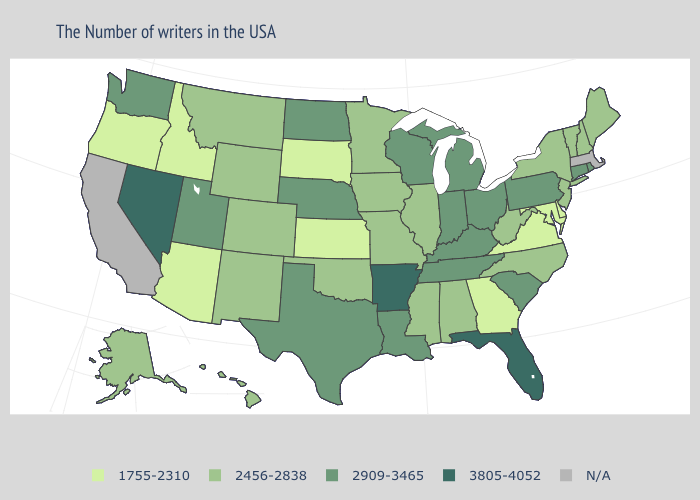Does Connecticut have the highest value in the Northeast?
Write a very short answer. Yes. Does Arkansas have the highest value in the South?
Answer briefly. Yes. What is the highest value in the USA?
Write a very short answer. 3805-4052. What is the value of Alaska?
Concise answer only. 2456-2838. Which states have the highest value in the USA?
Give a very brief answer. Florida, Arkansas, Nevada. Name the states that have a value in the range 1755-2310?
Write a very short answer. Delaware, Maryland, Virginia, Georgia, Kansas, South Dakota, Arizona, Idaho, Oregon. Name the states that have a value in the range 3805-4052?
Give a very brief answer. Florida, Arkansas, Nevada. What is the value of Kentucky?
Write a very short answer. 2909-3465. Among the states that border Utah , does Arizona have the lowest value?
Keep it brief. Yes. What is the value of Michigan?
Quick response, please. 2909-3465. What is the value of Delaware?
Concise answer only. 1755-2310. Name the states that have a value in the range 2909-3465?
Be succinct. Rhode Island, Connecticut, Pennsylvania, South Carolina, Ohio, Michigan, Kentucky, Indiana, Tennessee, Wisconsin, Louisiana, Nebraska, Texas, North Dakota, Utah, Washington. Which states have the lowest value in the USA?
Short answer required. Delaware, Maryland, Virginia, Georgia, Kansas, South Dakota, Arizona, Idaho, Oregon. Among the states that border North Dakota , does Minnesota have the lowest value?
Be succinct. No. How many symbols are there in the legend?
Concise answer only. 5. 